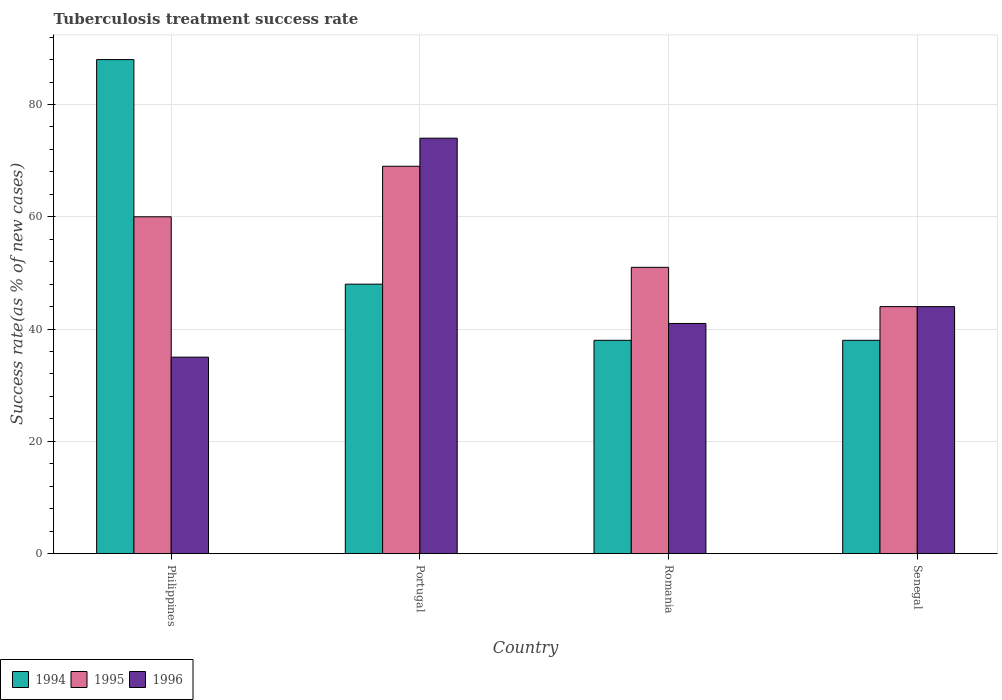How many different coloured bars are there?
Give a very brief answer. 3. How many groups of bars are there?
Your response must be concise. 4. Are the number of bars on each tick of the X-axis equal?
Offer a very short reply. Yes. In how many cases, is the number of bars for a given country not equal to the number of legend labels?
Give a very brief answer. 0. What is the tuberculosis treatment success rate in 1995 in Romania?
Keep it short and to the point. 51. Across all countries, what is the maximum tuberculosis treatment success rate in 1995?
Make the answer very short. 69. Across all countries, what is the minimum tuberculosis treatment success rate in 1995?
Your response must be concise. 44. In which country was the tuberculosis treatment success rate in 1996 maximum?
Offer a very short reply. Portugal. In which country was the tuberculosis treatment success rate in 1994 minimum?
Keep it short and to the point. Romania. What is the total tuberculosis treatment success rate in 1994 in the graph?
Make the answer very short. 212. What is the average tuberculosis treatment success rate in 1996 per country?
Your response must be concise. 48.5. In how many countries, is the tuberculosis treatment success rate in 1996 greater than 76 %?
Provide a succinct answer. 0. Is the tuberculosis treatment success rate in 1996 in Portugal less than that in Senegal?
Give a very brief answer. No. What does the 2nd bar from the right in Philippines represents?
Provide a succinct answer. 1995. How many bars are there?
Ensure brevity in your answer.  12. How many countries are there in the graph?
Provide a succinct answer. 4. Are the values on the major ticks of Y-axis written in scientific E-notation?
Your answer should be very brief. No. Does the graph contain any zero values?
Make the answer very short. No. What is the title of the graph?
Your answer should be compact. Tuberculosis treatment success rate. Does "1984" appear as one of the legend labels in the graph?
Give a very brief answer. No. What is the label or title of the X-axis?
Give a very brief answer. Country. What is the label or title of the Y-axis?
Provide a succinct answer. Success rate(as % of new cases). What is the Success rate(as % of new cases) in 1994 in Philippines?
Your answer should be very brief. 88. What is the Success rate(as % of new cases) in 1995 in Philippines?
Keep it short and to the point. 60. What is the Success rate(as % of new cases) in 1996 in Philippines?
Offer a terse response. 35. What is the Success rate(as % of new cases) of 1994 in Portugal?
Ensure brevity in your answer.  48. What is the Success rate(as % of new cases) of 1995 in Portugal?
Make the answer very short. 69. What is the Success rate(as % of new cases) in 1996 in Portugal?
Your response must be concise. 74. What is the Success rate(as % of new cases) in 1995 in Romania?
Offer a very short reply. 51. What is the Success rate(as % of new cases) in 1996 in Romania?
Keep it short and to the point. 41. What is the Success rate(as % of new cases) in 1996 in Senegal?
Your answer should be compact. 44. Across all countries, what is the maximum Success rate(as % of new cases) in 1994?
Give a very brief answer. 88. Across all countries, what is the maximum Success rate(as % of new cases) of 1995?
Ensure brevity in your answer.  69. Across all countries, what is the maximum Success rate(as % of new cases) of 1996?
Your answer should be very brief. 74. Across all countries, what is the minimum Success rate(as % of new cases) of 1994?
Give a very brief answer. 38. What is the total Success rate(as % of new cases) of 1994 in the graph?
Provide a succinct answer. 212. What is the total Success rate(as % of new cases) in 1995 in the graph?
Keep it short and to the point. 224. What is the total Success rate(as % of new cases) of 1996 in the graph?
Your response must be concise. 194. What is the difference between the Success rate(as % of new cases) of 1996 in Philippines and that in Portugal?
Give a very brief answer. -39. What is the difference between the Success rate(as % of new cases) of 1996 in Philippines and that in Romania?
Give a very brief answer. -6. What is the difference between the Success rate(as % of new cases) in 1995 in Philippines and that in Senegal?
Provide a short and direct response. 16. What is the difference between the Success rate(as % of new cases) in 1996 in Philippines and that in Senegal?
Provide a succinct answer. -9. What is the difference between the Success rate(as % of new cases) in 1994 in Portugal and that in Romania?
Give a very brief answer. 10. What is the difference between the Success rate(as % of new cases) in 1996 in Romania and that in Senegal?
Provide a short and direct response. -3. What is the difference between the Success rate(as % of new cases) in 1994 in Philippines and the Success rate(as % of new cases) in 1996 in Romania?
Offer a very short reply. 47. What is the difference between the Success rate(as % of new cases) in 1995 in Philippines and the Success rate(as % of new cases) in 1996 in Romania?
Give a very brief answer. 19. What is the difference between the Success rate(as % of new cases) in 1994 in Philippines and the Success rate(as % of new cases) in 1995 in Senegal?
Provide a succinct answer. 44. What is the difference between the Success rate(as % of new cases) of 1994 in Philippines and the Success rate(as % of new cases) of 1996 in Senegal?
Your answer should be compact. 44. What is the difference between the Success rate(as % of new cases) in 1995 in Philippines and the Success rate(as % of new cases) in 1996 in Senegal?
Keep it short and to the point. 16. What is the difference between the Success rate(as % of new cases) of 1994 in Romania and the Success rate(as % of new cases) of 1995 in Senegal?
Keep it short and to the point. -6. What is the difference between the Success rate(as % of new cases) in 1994 in Romania and the Success rate(as % of new cases) in 1996 in Senegal?
Your response must be concise. -6. What is the average Success rate(as % of new cases) of 1995 per country?
Your answer should be compact. 56. What is the average Success rate(as % of new cases) in 1996 per country?
Your response must be concise. 48.5. What is the difference between the Success rate(as % of new cases) of 1994 and Success rate(as % of new cases) of 1995 in Philippines?
Provide a succinct answer. 28. What is the difference between the Success rate(as % of new cases) of 1994 and Success rate(as % of new cases) of 1996 in Philippines?
Make the answer very short. 53. What is the difference between the Success rate(as % of new cases) in 1994 and Success rate(as % of new cases) in 1995 in Portugal?
Your answer should be very brief. -21. What is the difference between the Success rate(as % of new cases) of 1994 and Success rate(as % of new cases) of 1995 in Romania?
Keep it short and to the point. -13. What is the difference between the Success rate(as % of new cases) in 1994 and Success rate(as % of new cases) in 1996 in Romania?
Offer a very short reply. -3. What is the difference between the Success rate(as % of new cases) of 1995 and Success rate(as % of new cases) of 1996 in Romania?
Ensure brevity in your answer.  10. What is the difference between the Success rate(as % of new cases) of 1994 and Success rate(as % of new cases) of 1996 in Senegal?
Give a very brief answer. -6. What is the difference between the Success rate(as % of new cases) in 1995 and Success rate(as % of new cases) in 1996 in Senegal?
Your answer should be very brief. 0. What is the ratio of the Success rate(as % of new cases) of 1994 in Philippines to that in Portugal?
Your answer should be compact. 1.83. What is the ratio of the Success rate(as % of new cases) in 1995 in Philippines to that in Portugal?
Make the answer very short. 0.87. What is the ratio of the Success rate(as % of new cases) of 1996 in Philippines to that in Portugal?
Give a very brief answer. 0.47. What is the ratio of the Success rate(as % of new cases) in 1994 in Philippines to that in Romania?
Provide a succinct answer. 2.32. What is the ratio of the Success rate(as % of new cases) of 1995 in Philippines to that in Romania?
Make the answer very short. 1.18. What is the ratio of the Success rate(as % of new cases) of 1996 in Philippines to that in Romania?
Your answer should be very brief. 0.85. What is the ratio of the Success rate(as % of new cases) in 1994 in Philippines to that in Senegal?
Provide a short and direct response. 2.32. What is the ratio of the Success rate(as % of new cases) in 1995 in Philippines to that in Senegal?
Offer a very short reply. 1.36. What is the ratio of the Success rate(as % of new cases) of 1996 in Philippines to that in Senegal?
Your answer should be compact. 0.8. What is the ratio of the Success rate(as % of new cases) of 1994 in Portugal to that in Romania?
Make the answer very short. 1.26. What is the ratio of the Success rate(as % of new cases) in 1995 in Portugal to that in Romania?
Keep it short and to the point. 1.35. What is the ratio of the Success rate(as % of new cases) of 1996 in Portugal to that in Romania?
Keep it short and to the point. 1.8. What is the ratio of the Success rate(as % of new cases) in 1994 in Portugal to that in Senegal?
Keep it short and to the point. 1.26. What is the ratio of the Success rate(as % of new cases) in 1995 in Portugal to that in Senegal?
Ensure brevity in your answer.  1.57. What is the ratio of the Success rate(as % of new cases) in 1996 in Portugal to that in Senegal?
Your answer should be very brief. 1.68. What is the ratio of the Success rate(as % of new cases) in 1995 in Romania to that in Senegal?
Keep it short and to the point. 1.16. What is the ratio of the Success rate(as % of new cases) of 1996 in Romania to that in Senegal?
Your answer should be very brief. 0.93. What is the difference between the highest and the second highest Success rate(as % of new cases) of 1996?
Offer a terse response. 30. What is the difference between the highest and the lowest Success rate(as % of new cases) of 1996?
Provide a succinct answer. 39. 